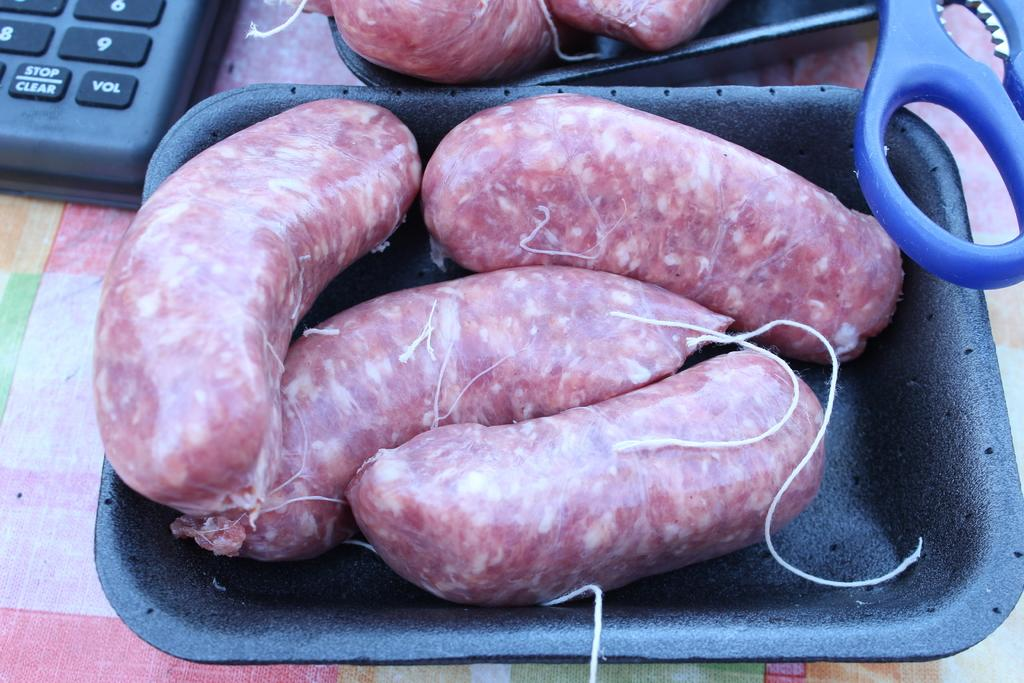What type of food is visible in the image? There are sausages in the image. How are the sausages arranged or stored? The sausages are kept in two bowls. What tool is present in the image? There is a scissors in the image. What communication device can be seen in the image? There is a landline phone in the image. What type of engine is visible in the image? There is no engine present in the image. How much tax is being paid for the sausages in the image? There is no indication of tax being paid for the sausages in the image. 